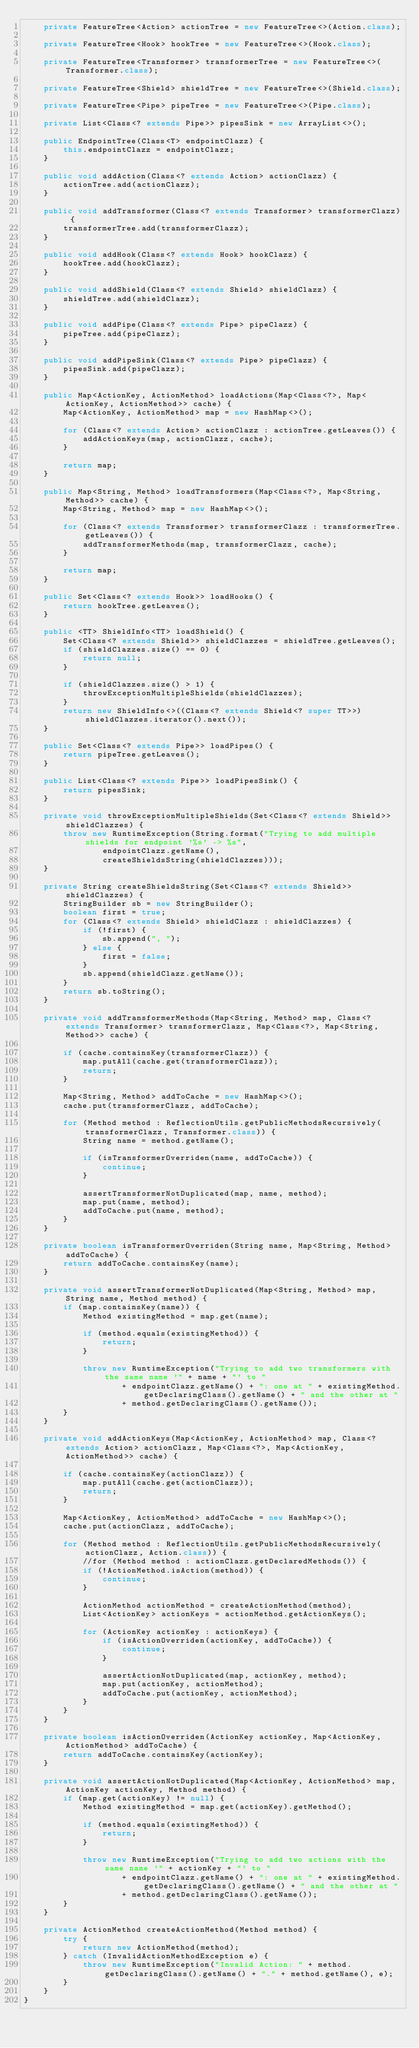Convert code to text. <code><loc_0><loc_0><loc_500><loc_500><_Java_>    private FeatureTree<Action> actionTree = new FeatureTree<>(Action.class);

    private FeatureTree<Hook> hookTree = new FeatureTree<>(Hook.class);

    private FeatureTree<Transformer> transformerTree = new FeatureTree<>(Transformer.class);

    private FeatureTree<Shield> shieldTree = new FeatureTree<>(Shield.class);

    private FeatureTree<Pipe> pipeTree = new FeatureTree<>(Pipe.class);

    private List<Class<? extends Pipe>> pipesSink = new ArrayList<>();

    public EndpointTree(Class<T> endpointClazz) {
        this.endpointClazz = endpointClazz;
    }

    public void addAction(Class<? extends Action> actionClazz) {
        actionTree.add(actionClazz);
    }

    public void addTransformer(Class<? extends Transformer> transformerClazz) {
        transformerTree.add(transformerClazz);
    }

    public void addHook(Class<? extends Hook> hookClazz) {
        hookTree.add(hookClazz);
    }

    public void addShield(Class<? extends Shield> shieldClazz) {
        shieldTree.add(shieldClazz);
    }

    public void addPipe(Class<? extends Pipe> pipeClazz) {
        pipeTree.add(pipeClazz);
    }

    public void addPipeSink(Class<? extends Pipe> pipeClazz) {
        pipesSink.add(pipeClazz);
    }

    public Map<ActionKey, ActionMethod> loadActions(Map<Class<?>, Map<ActionKey, ActionMethod>> cache) {
        Map<ActionKey, ActionMethod> map = new HashMap<>();

        for (Class<? extends Action> actionClazz : actionTree.getLeaves()) {
            addActionKeys(map, actionClazz, cache);
        }

        return map;
    }

    public Map<String, Method> loadTransformers(Map<Class<?>, Map<String, Method>> cache) {
        Map<String, Method> map = new HashMap<>();

        for (Class<? extends Transformer> transformerClazz : transformerTree.getLeaves()) {
            addTransformerMethods(map, transformerClazz, cache);
        }

        return map;
    }

    public Set<Class<? extends Hook>> loadHooks() {
        return hookTree.getLeaves();
    }

    public <TT> ShieldInfo<TT> loadShield() {
        Set<Class<? extends Shield>> shieldClazzes = shieldTree.getLeaves();
        if (shieldClazzes.size() == 0) {
            return null;
        }

        if (shieldClazzes.size() > 1) {
            throwExceptionMultipleShields(shieldClazzes);
        }
        return new ShieldInfo<>((Class<? extends Shield<? super TT>>) shieldClazzes.iterator().next());
    }

    public Set<Class<? extends Pipe>> loadPipes() {
        return pipeTree.getLeaves();
    }

    public List<Class<? extends Pipe>> loadPipesSink() {
        return pipesSink;
    }

    private void throwExceptionMultipleShields(Set<Class<? extends Shield>> shieldClazzes) {
        throw new RuntimeException(String.format("Trying to add multiple shields for endpoint '%s' -> %s",
                endpointClazz.getName(),
                createShieldsString(shieldClazzes)));
    }

    private String createShieldsString(Set<Class<? extends Shield>> shieldClazzes) {
        StringBuilder sb = new StringBuilder();
        boolean first = true;
        for (Class<? extends Shield> shieldClazz : shieldClazzes) {
            if (!first) {
                sb.append(", ");
            } else {
                first = false;
            }
            sb.append(shieldClazz.getName());
        }
        return sb.toString();
    }

    private void addTransformerMethods(Map<String, Method> map, Class<? extends Transformer> transformerClazz, Map<Class<?>, Map<String, Method>> cache) {

        if (cache.containsKey(transformerClazz)) {
            map.putAll(cache.get(transformerClazz));
            return;
        }

        Map<String, Method> addToCache = new HashMap<>();
        cache.put(transformerClazz, addToCache);

        for (Method method : ReflectionUtils.getPublicMethodsRecursively(transformerClazz, Transformer.class)) {
            String name = method.getName();

            if (isTransformerOverriden(name, addToCache)) {
                continue;
            }

            assertTransformerNotDuplicated(map, name, method);
            map.put(name, method);
            addToCache.put(name, method);
        }
    }

    private boolean isTransformerOverriden(String name, Map<String, Method> addToCache) {
        return addToCache.containsKey(name);
    }

    private void assertTransformerNotDuplicated(Map<String, Method> map, String name, Method method) {
        if (map.containsKey(name)) {
            Method existingMethod = map.get(name);

            if (method.equals(existingMethod)) {
                return;
            }

            throw new RuntimeException("Trying to add two transformers with the same name '" + name + "' to "
                    + endpointClazz.getName() + ": one at " + existingMethod.getDeclaringClass().getName() + " and the other at "
                    + method.getDeclaringClass().getName());
        }
    }

    private void addActionKeys(Map<ActionKey, ActionMethod> map, Class<? extends Action> actionClazz, Map<Class<?>, Map<ActionKey, ActionMethod>> cache) {

        if (cache.containsKey(actionClazz)) {
            map.putAll(cache.get(actionClazz));
            return;
        }

        Map<ActionKey, ActionMethod> addToCache = new HashMap<>();
        cache.put(actionClazz, addToCache);

        for (Method method : ReflectionUtils.getPublicMethodsRecursively(actionClazz, Action.class)) {
            //for (Method method : actionClazz.getDeclaredMethods()) {
            if (!ActionMethod.isAction(method)) {
                continue;
            }

            ActionMethod actionMethod = createActionMethod(method);
            List<ActionKey> actionKeys = actionMethod.getActionKeys();

            for (ActionKey actionKey : actionKeys) {
                if (isActionOverriden(actionKey, addToCache)) {
                    continue;
                }

                assertActionNotDuplicated(map, actionKey, method);
                map.put(actionKey, actionMethod);
                addToCache.put(actionKey, actionMethod);
            }
        }
    }

    private boolean isActionOverriden(ActionKey actionKey, Map<ActionKey, ActionMethod> addToCache) {
        return addToCache.containsKey(actionKey);
    }

    private void assertActionNotDuplicated(Map<ActionKey, ActionMethod> map, ActionKey actionKey, Method method) {
        if (map.get(actionKey) != null) {
            Method existingMethod = map.get(actionKey).getMethod();

            if (method.equals(existingMethod)) {
                return;
            }

            throw new RuntimeException("Trying to add two actions with the same name '" + actionKey + "' to "
                    + endpointClazz.getName() + ": one at " + existingMethod.getDeclaringClass().getName() + " and the other at "
                    + method.getDeclaringClass().getName());
        }
    }

    private ActionMethod createActionMethod(Method method) {
        try {
            return new ActionMethod(method);
        } catch (InvalidActionMethodException e) {
            throw new RuntimeException("Invalid Action: " + method.getDeclaringClass().getName() + "." + method.getName(), e);
        }
    }
}
</code> 